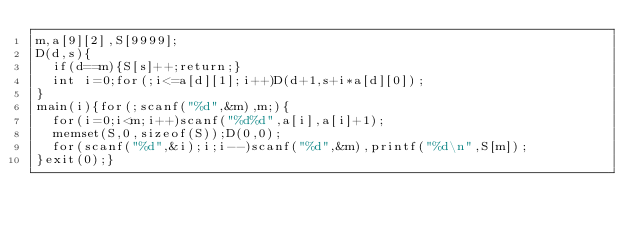Convert code to text. <code><loc_0><loc_0><loc_500><loc_500><_C_>m,a[9][2],S[9999];
D(d,s){
	if(d==m){S[s]++;return;}
	int i=0;for(;i<=a[d][1];i++)D(d+1,s+i*a[d][0]);
}
main(i){for(;scanf("%d",&m),m;){
	for(i=0;i<m;i++)scanf("%d%d",a[i],a[i]+1);
	memset(S,0,sizeof(S));D(0,0);
	for(scanf("%d",&i);i;i--)scanf("%d",&m),printf("%d\n",S[m]);
}exit(0);}</code> 